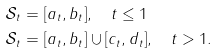Convert formula to latex. <formula><loc_0><loc_0><loc_500><loc_500>\mathcal { S } _ { t } & = [ a _ { t } , b _ { t } ] , \quad t \leq 1 \\ \mathcal { S } _ { t } & = [ a _ { t } , b _ { t } ] \cup [ c _ { t } , d _ { t } ] , \quad t > 1 .</formula> 